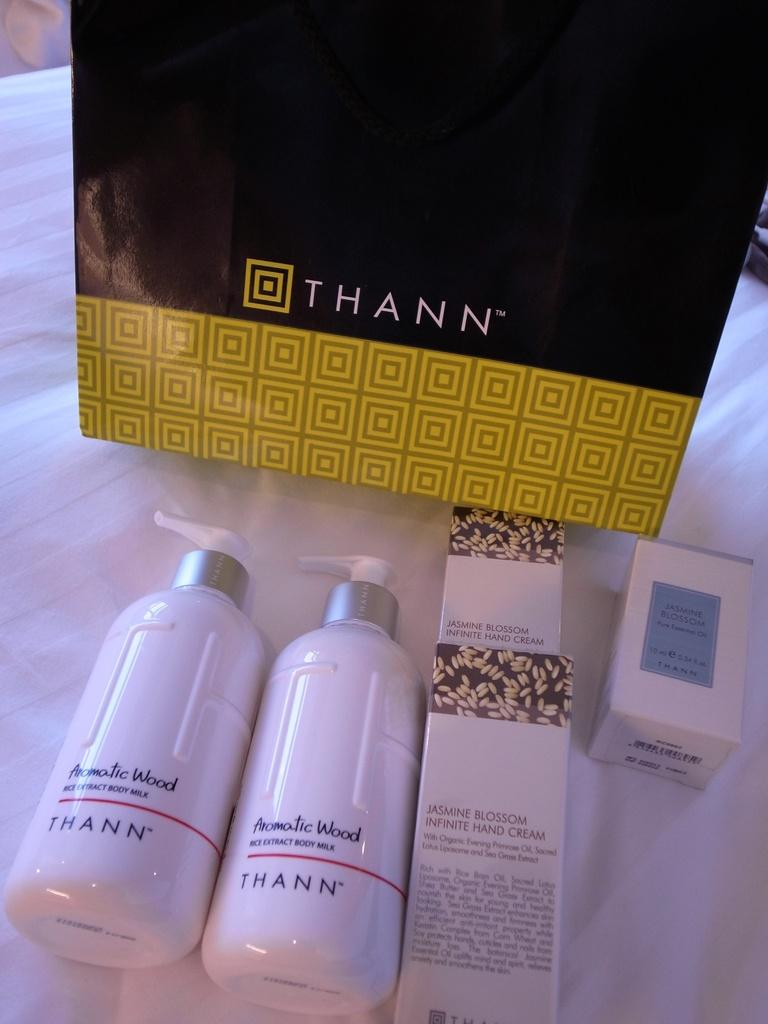<image>
Write a terse but informative summary of the picture. Thann beauty products placed in front of a Thann bag. 